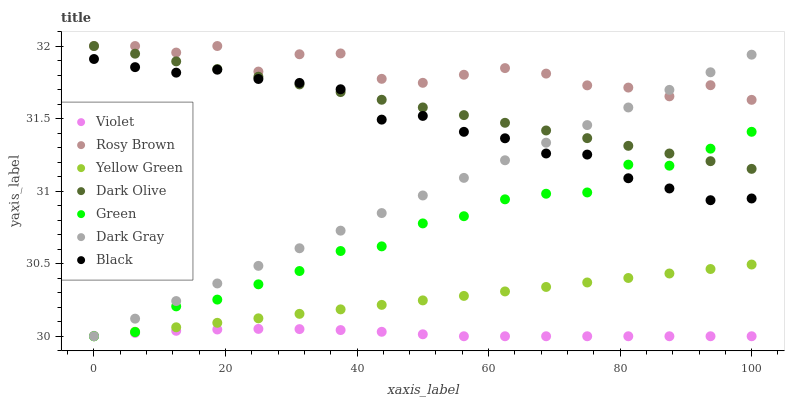Does Violet have the minimum area under the curve?
Answer yes or no. Yes. Does Rosy Brown have the maximum area under the curve?
Answer yes or no. Yes. Does Yellow Green have the minimum area under the curve?
Answer yes or no. No. Does Yellow Green have the maximum area under the curve?
Answer yes or no. No. Is Dark Olive the smoothest?
Answer yes or no. Yes. Is Rosy Brown the roughest?
Answer yes or no. Yes. Is Yellow Green the smoothest?
Answer yes or no. No. Is Yellow Green the roughest?
Answer yes or no. No. Does Yellow Green have the lowest value?
Answer yes or no. Yes. Does Dark Olive have the lowest value?
Answer yes or no. No. Does Dark Olive have the highest value?
Answer yes or no. Yes. Does Yellow Green have the highest value?
Answer yes or no. No. Is Violet less than Black?
Answer yes or no. Yes. Is Dark Olive greater than Violet?
Answer yes or no. Yes. Does Dark Olive intersect Dark Gray?
Answer yes or no. Yes. Is Dark Olive less than Dark Gray?
Answer yes or no. No. Is Dark Olive greater than Dark Gray?
Answer yes or no. No. Does Violet intersect Black?
Answer yes or no. No. 